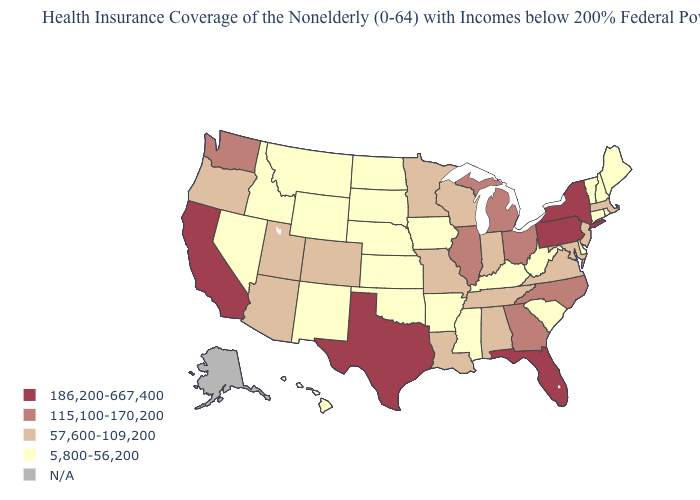Among the states that border Washington , does Idaho have the highest value?
Be succinct. No. What is the value of Minnesota?
Be succinct. 57,600-109,200. Name the states that have a value in the range 5,800-56,200?
Quick response, please. Arkansas, Connecticut, Delaware, Hawaii, Idaho, Iowa, Kansas, Kentucky, Maine, Mississippi, Montana, Nebraska, Nevada, New Hampshire, New Mexico, North Dakota, Oklahoma, Rhode Island, South Carolina, South Dakota, Vermont, West Virginia, Wyoming. Is the legend a continuous bar?
Answer briefly. No. Does Texas have the highest value in the USA?
Quick response, please. Yes. Name the states that have a value in the range 186,200-667,400?
Be succinct. California, Florida, New York, Pennsylvania, Texas. What is the value of Oregon?
Concise answer only. 57,600-109,200. Among the states that border Illinois , does Kentucky have the lowest value?
Be succinct. Yes. What is the highest value in states that border Montana?
Quick response, please. 5,800-56,200. Among the states that border Wisconsin , which have the highest value?
Be succinct. Illinois, Michigan. Does the first symbol in the legend represent the smallest category?
Give a very brief answer. No. Is the legend a continuous bar?
Short answer required. No. Does Wyoming have the lowest value in the West?
Answer briefly. Yes. What is the value of Georgia?
Keep it brief. 115,100-170,200. 